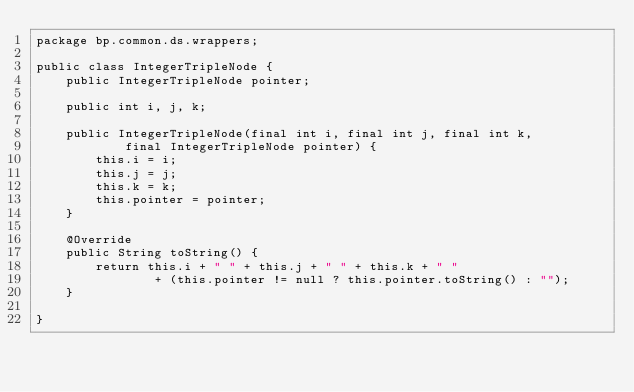<code> <loc_0><loc_0><loc_500><loc_500><_Java_>package bp.common.ds.wrappers;

public class IntegerTripleNode {
    public IntegerTripleNode pointer;

    public int i, j, k;

    public IntegerTripleNode(final int i, final int j, final int k,
            final IntegerTripleNode pointer) {
        this.i = i;
        this.j = j;
        this.k = k;
        this.pointer = pointer;
    }

    @Override
	public String toString() {
        return this.i + " " + this.j + " " + this.k + " "
                + (this.pointer != null ? this.pointer.toString() : "");
    }

}</code> 